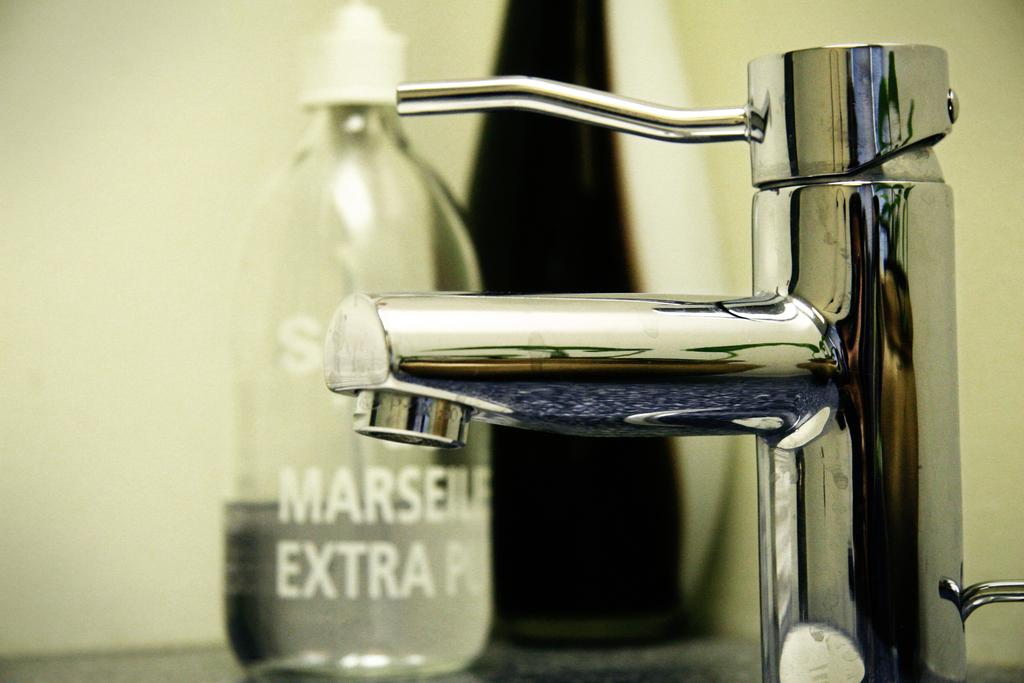<image>
Offer a succinct explanation of the picture presented. the word extra is on a clear bottle 